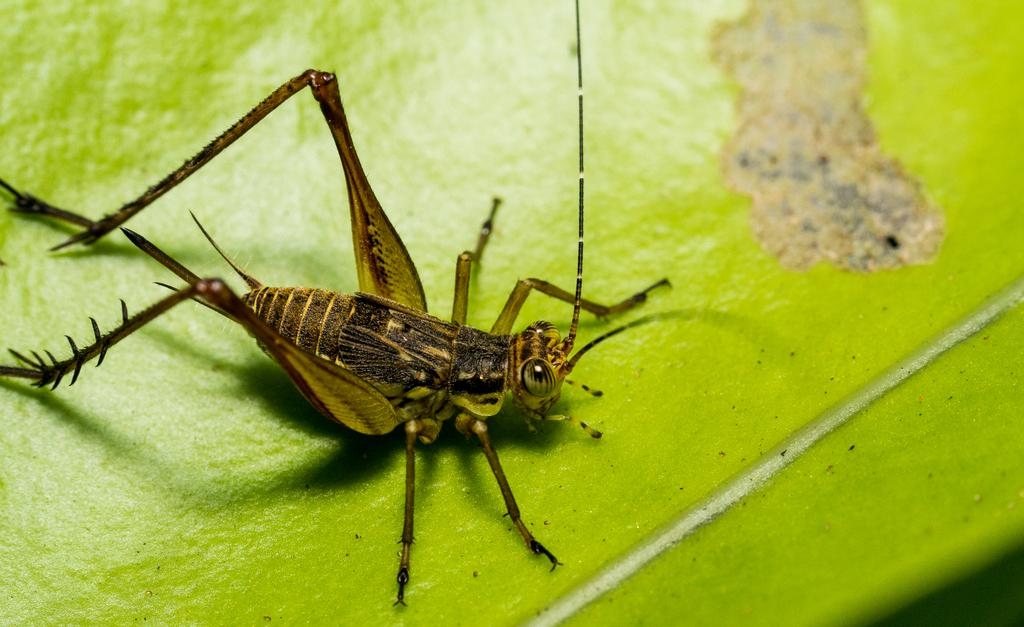What is the main subject of the image? There is an inset in the image. Can you describe the location of the inset? The inset is standing on a green table. What type of boat can be seen sailing in the image? There is no boat present in the image; it features an inset standing on a green table. How many cherries are visible on the table in the image? There are no cherries present in the image; it only features an inset standing on a green table. 